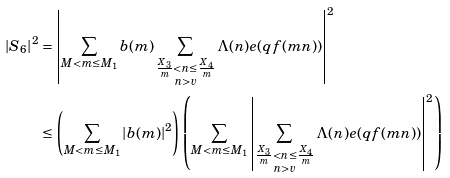<formula> <loc_0><loc_0><loc_500><loc_500>\left | S _ { 6 } \right | ^ { 2 } & = \left | \sum _ { M < m \leq M _ { 1 } } b ( m ) \sum _ { \substack { \frac { X _ { 3 } } { m } < n \leq \frac { X _ { 4 } } { m } \\ n > v } } \Lambda ( n ) e ( q f ( m n ) ) \right | ^ { 2 } \\ & \leq \left ( \sum _ { M < m \leq M _ { 1 } } | b ( m ) | ^ { 2 } \right ) \left ( \sum _ { M < m \leq M _ { 1 } } \left | \sum _ { \substack { \frac { X _ { 3 } } { m } < n \leq \frac { X _ { 4 } } { m } \\ n > v } } \Lambda ( n ) e ( q f ( m n ) ) \right | ^ { 2 } \right )</formula> 